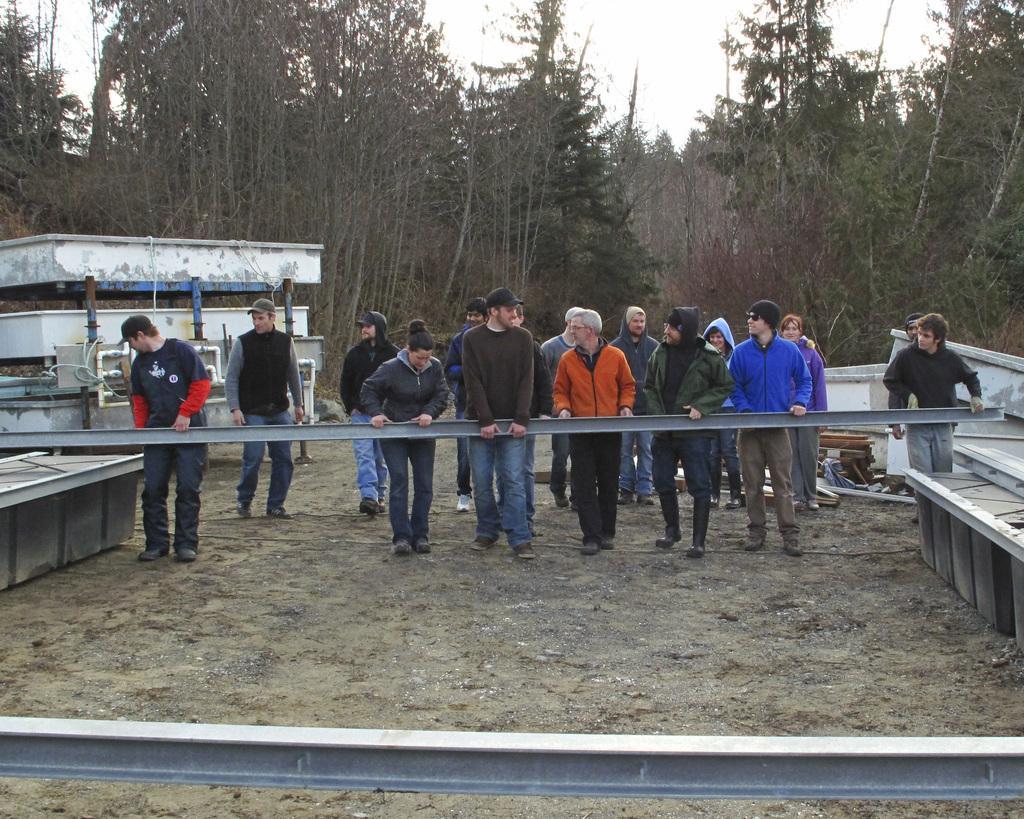Please provide a concise description of this image. In this image I can see the group of people with different color dresses. I can see few people are wearing the caps and few people are holding the metal object. I can see few more metal objects. In the background I can see many objects, buildings, trees and the sky. 